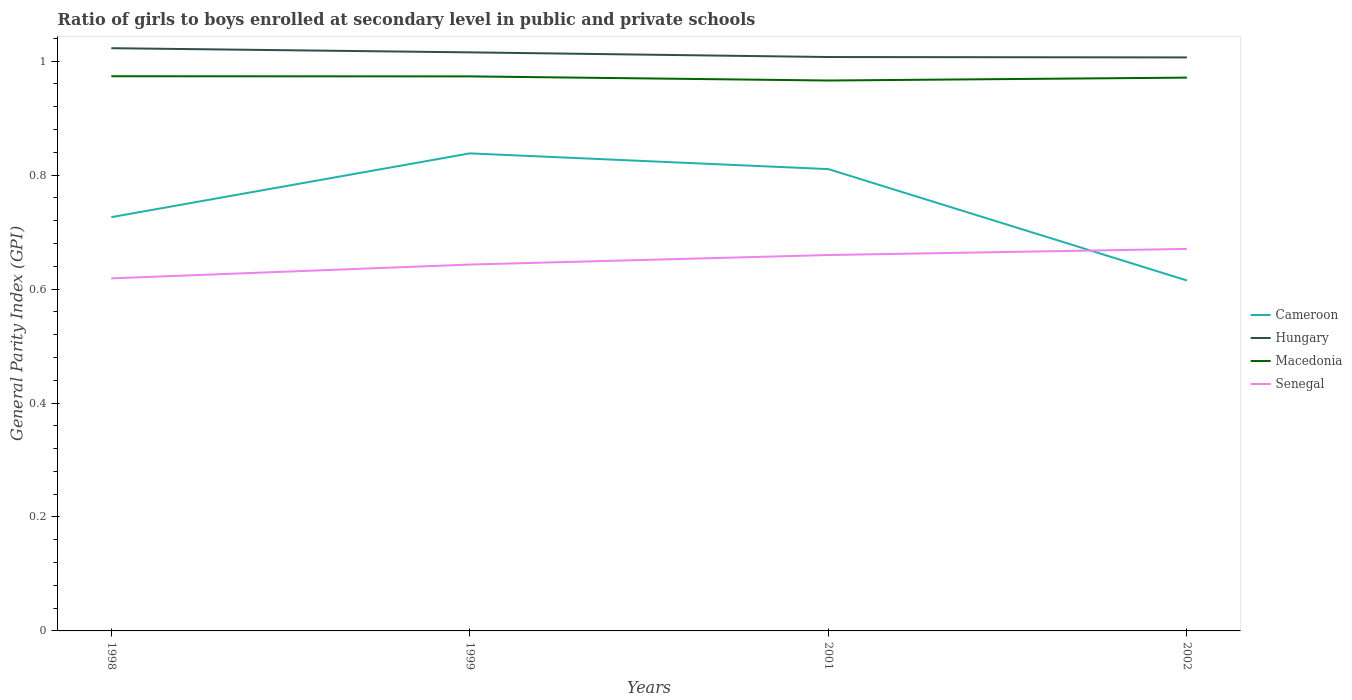Across all years, what is the maximum general parity index in Hungary?
Your answer should be compact. 1.01. What is the total general parity index in Hungary in the graph?
Ensure brevity in your answer.  0.01. What is the difference between the highest and the second highest general parity index in Cameroon?
Offer a terse response. 0.22. What is the difference between the highest and the lowest general parity index in Macedonia?
Keep it short and to the point. 3. Is the general parity index in Senegal strictly greater than the general parity index in Cameroon over the years?
Your response must be concise. No. What is the difference between two consecutive major ticks on the Y-axis?
Provide a succinct answer. 0.2. Does the graph contain any zero values?
Provide a succinct answer. No. What is the title of the graph?
Provide a short and direct response. Ratio of girls to boys enrolled at secondary level in public and private schools. Does "Iceland" appear as one of the legend labels in the graph?
Provide a short and direct response. No. What is the label or title of the Y-axis?
Offer a terse response. General Parity Index (GPI). What is the General Parity Index (GPI) in Cameroon in 1998?
Ensure brevity in your answer.  0.73. What is the General Parity Index (GPI) in Hungary in 1998?
Keep it short and to the point. 1.02. What is the General Parity Index (GPI) in Macedonia in 1998?
Your answer should be compact. 0.97. What is the General Parity Index (GPI) of Senegal in 1998?
Offer a terse response. 0.62. What is the General Parity Index (GPI) of Cameroon in 1999?
Your response must be concise. 0.84. What is the General Parity Index (GPI) in Hungary in 1999?
Your answer should be compact. 1.02. What is the General Parity Index (GPI) in Macedonia in 1999?
Your response must be concise. 0.97. What is the General Parity Index (GPI) in Senegal in 1999?
Offer a terse response. 0.64. What is the General Parity Index (GPI) in Cameroon in 2001?
Give a very brief answer. 0.81. What is the General Parity Index (GPI) in Hungary in 2001?
Provide a short and direct response. 1.01. What is the General Parity Index (GPI) of Macedonia in 2001?
Provide a succinct answer. 0.97. What is the General Parity Index (GPI) of Senegal in 2001?
Your answer should be compact. 0.66. What is the General Parity Index (GPI) in Cameroon in 2002?
Provide a succinct answer. 0.62. What is the General Parity Index (GPI) in Hungary in 2002?
Provide a short and direct response. 1.01. What is the General Parity Index (GPI) of Macedonia in 2002?
Offer a very short reply. 0.97. What is the General Parity Index (GPI) of Senegal in 2002?
Keep it short and to the point. 0.67. Across all years, what is the maximum General Parity Index (GPI) in Cameroon?
Your response must be concise. 0.84. Across all years, what is the maximum General Parity Index (GPI) in Hungary?
Ensure brevity in your answer.  1.02. Across all years, what is the maximum General Parity Index (GPI) in Macedonia?
Ensure brevity in your answer.  0.97. Across all years, what is the maximum General Parity Index (GPI) in Senegal?
Your answer should be very brief. 0.67. Across all years, what is the minimum General Parity Index (GPI) of Cameroon?
Your answer should be very brief. 0.62. Across all years, what is the minimum General Parity Index (GPI) of Hungary?
Your answer should be compact. 1.01. Across all years, what is the minimum General Parity Index (GPI) in Macedonia?
Make the answer very short. 0.97. Across all years, what is the minimum General Parity Index (GPI) of Senegal?
Provide a succinct answer. 0.62. What is the total General Parity Index (GPI) of Cameroon in the graph?
Your response must be concise. 2.99. What is the total General Parity Index (GPI) of Hungary in the graph?
Offer a terse response. 4.05. What is the total General Parity Index (GPI) in Macedonia in the graph?
Offer a terse response. 3.88. What is the total General Parity Index (GPI) in Senegal in the graph?
Offer a terse response. 2.59. What is the difference between the General Parity Index (GPI) of Cameroon in 1998 and that in 1999?
Offer a terse response. -0.11. What is the difference between the General Parity Index (GPI) in Hungary in 1998 and that in 1999?
Provide a short and direct response. 0.01. What is the difference between the General Parity Index (GPI) in Senegal in 1998 and that in 1999?
Your answer should be compact. -0.02. What is the difference between the General Parity Index (GPI) in Cameroon in 1998 and that in 2001?
Offer a very short reply. -0.08. What is the difference between the General Parity Index (GPI) in Hungary in 1998 and that in 2001?
Provide a short and direct response. 0.02. What is the difference between the General Parity Index (GPI) in Macedonia in 1998 and that in 2001?
Make the answer very short. 0.01. What is the difference between the General Parity Index (GPI) in Senegal in 1998 and that in 2001?
Keep it short and to the point. -0.04. What is the difference between the General Parity Index (GPI) of Cameroon in 1998 and that in 2002?
Provide a short and direct response. 0.11. What is the difference between the General Parity Index (GPI) of Hungary in 1998 and that in 2002?
Provide a succinct answer. 0.02. What is the difference between the General Parity Index (GPI) in Macedonia in 1998 and that in 2002?
Offer a very short reply. 0. What is the difference between the General Parity Index (GPI) of Senegal in 1998 and that in 2002?
Offer a terse response. -0.05. What is the difference between the General Parity Index (GPI) of Cameroon in 1999 and that in 2001?
Give a very brief answer. 0.03. What is the difference between the General Parity Index (GPI) of Hungary in 1999 and that in 2001?
Provide a succinct answer. 0.01. What is the difference between the General Parity Index (GPI) in Macedonia in 1999 and that in 2001?
Your answer should be very brief. 0.01. What is the difference between the General Parity Index (GPI) of Senegal in 1999 and that in 2001?
Ensure brevity in your answer.  -0.02. What is the difference between the General Parity Index (GPI) of Cameroon in 1999 and that in 2002?
Your answer should be compact. 0.22. What is the difference between the General Parity Index (GPI) in Hungary in 1999 and that in 2002?
Your answer should be very brief. 0.01. What is the difference between the General Parity Index (GPI) of Macedonia in 1999 and that in 2002?
Give a very brief answer. 0. What is the difference between the General Parity Index (GPI) in Senegal in 1999 and that in 2002?
Ensure brevity in your answer.  -0.03. What is the difference between the General Parity Index (GPI) of Cameroon in 2001 and that in 2002?
Offer a very short reply. 0.2. What is the difference between the General Parity Index (GPI) of Hungary in 2001 and that in 2002?
Your response must be concise. 0. What is the difference between the General Parity Index (GPI) in Macedonia in 2001 and that in 2002?
Offer a very short reply. -0.01. What is the difference between the General Parity Index (GPI) in Senegal in 2001 and that in 2002?
Give a very brief answer. -0.01. What is the difference between the General Parity Index (GPI) of Cameroon in 1998 and the General Parity Index (GPI) of Hungary in 1999?
Ensure brevity in your answer.  -0.29. What is the difference between the General Parity Index (GPI) in Cameroon in 1998 and the General Parity Index (GPI) in Macedonia in 1999?
Provide a short and direct response. -0.25. What is the difference between the General Parity Index (GPI) of Cameroon in 1998 and the General Parity Index (GPI) of Senegal in 1999?
Keep it short and to the point. 0.08. What is the difference between the General Parity Index (GPI) of Hungary in 1998 and the General Parity Index (GPI) of Macedonia in 1999?
Make the answer very short. 0.05. What is the difference between the General Parity Index (GPI) in Hungary in 1998 and the General Parity Index (GPI) in Senegal in 1999?
Provide a succinct answer. 0.38. What is the difference between the General Parity Index (GPI) in Macedonia in 1998 and the General Parity Index (GPI) in Senegal in 1999?
Make the answer very short. 0.33. What is the difference between the General Parity Index (GPI) in Cameroon in 1998 and the General Parity Index (GPI) in Hungary in 2001?
Your answer should be very brief. -0.28. What is the difference between the General Parity Index (GPI) of Cameroon in 1998 and the General Parity Index (GPI) of Macedonia in 2001?
Provide a succinct answer. -0.24. What is the difference between the General Parity Index (GPI) of Cameroon in 1998 and the General Parity Index (GPI) of Senegal in 2001?
Give a very brief answer. 0.07. What is the difference between the General Parity Index (GPI) in Hungary in 1998 and the General Parity Index (GPI) in Macedonia in 2001?
Provide a short and direct response. 0.06. What is the difference between the General Parity Index (GPI) of Hungary in 1998 and the General Parity Index (GPI) of Senegal in 2001?
Your response must be concise. 0.36. What is the difference between the General Parity Index (GPI) in Macedonia in 1998 and the General Parity Index (GPI) in Senegal in 2001?
Offer a very short reply. 0.31. What is the difference between the General Parity Index (GPI) in Cameroon in 1998 and the General Parity Index (GPI) in Hungary in 2002?
Provide a short and direct response. -0.28. What is the difference between the General Parity Index (GPI) in Cameroon in 1998 and the General Parity Index (GPI) in Macedonia in 2002?
Offer a very short reply. -0.24. What is the difference between the General Parity Index (GPI) in Cameroon in 1998 and the General Parity Index (GPI) in Senegal in 2002?
Offer a very short reply. 0.06. What is the difference between the General Parity Index (GPI) in Hungary in 1998 and the General Parity Index (GPI) in Macedonia in 2002?
Give a very brief answer. 0.05. What is the difference between the General Parity Index (GPI) of Hungary in 1998 and the General Parity Index (GPI) of Senegal in 2002?
Provide a succinct answer. 0.35. What is the difference between the General Parity Index (GPI) in Macedonia in 1998 and the General Parity Index (GPI) in Senegal in 2002?
Your answer should be compact. 0.3. What is the difference between the General Parity Index (GPI) in Cameroon in 1999 and the General Parity Index (GPI) in Hungary in 2001?
Your response must be concise. -0.17. What is the difference between the General Parity Index (GPI) in Cameroon in 1999 and the General Parity Index (GPI) in Macedonia in 2001?
Your answer should be very brief. -0.13. What is the difference between the General Parity Index (GPI) of Cameroon in 1999 and the General Parity Index (GPI) of Senegal in 2001?
Give a very brief answer. 0.18. What is the difference between the General Parity Index (GPI) of Hungary in 1999 and the General Parity Index (GPI) of Macedonia in 2001?
Give a very brief answer. 0.05. What is the difference between the General Parity Index (GPI) of Hungary in 1999 and the General Parity Index (GPI) of Senegal in 2001?
Your response must be concise. 0.36. What is the difference between the General Parity Index (GPI) in Macedonia in 1999 and the General Parity Index (GPI) in Senegal in 2001?
Offer a very short reply. 0.31. What is the difference between the General Parity Index (GPI) of Cameroon in 1999 and the General Parity Index (GPI) of Hungary in 2002?
Your response must be concise. -0.17. What is the difference between the General Parity Index (GPI) in Cameroon in 1999 and the General Parity Index (GPI) in Macedonia in 2002?
Give a very brief answer. -0.13. What is the difference between the General Parity Index (GPI) in Cameroon in 1999 and the General Parity Index (GPI) in Senegal in 2002?
Offer a terse response. 0.17. What is the difference between the General Parity Index (GPI) in Hungary in 1999 and the General Parity Index (GPI) in Macedonia in 2002?
Your answer should be very brief. 0.04. What is the difference between the General Parity Index (GPI) in Hungary in 1999 and the General Parity Index (GPI) in Senegal in 2002?
Offer a terse response. 0.34. What is the difference between the General Parity Index (GPI) of Macedonia in 1999 and the General Parity Index (GPI) of Senegal in 2002?
Keep it short and to the point. 0.3. What is the difference between the General Parity Index (GPI) of Cameroon in 2001 and the General Parity Index (GPI) of Hungary in 2002?
Offer a very short reply. -0.2. What is the difference between the General Parity Index (GPI) of Cameroon in 2001 and the General Parity Index (GPI) of Macedonia in 2002?
Give a very brief answer. -0.16. What is the difference between the General Parity Index (GPI) of Cameroon in 2001 and the General Parity Index (GPI) of Senegal in 2002?
Offer a terse response. 0.14. What is the difference between the General Parity Index (GPI) in Hungary in 2001 and the General Parity Index (GPI) in Macedonia in 2002?
Provide a succinct answer. 0.04. What is the difference between the General Parity Index (GPI) of Hungary in 2001 and the General Parity Index (GPI) of Senegal in 2002?
Offer a terse response. 0.34. What is the difference between the General Parity Index (GPI) of Macedonia in 2001 and the General Parity Index (GPI) of Senegal in 2002?
Provide a succinct answer. 0.3. What is the average General Parity Index (GPI) of Cameroon per year?
Make the answer very short. 0.75. What is the average General Parity Index (GPI) of Hungary per year?
Ensure brevity in your answer.  1.01. What is the average General Parity Index (GPI) of Macedonia per year?
Your answer should be compact. 0.97. What is the average General Parity Index (GPI) of Senegal per year?
Keep it short and to the point. 0.65. In the year 1998, what is the difference between the General Parity Index (GPI) of Cameroon and General Parity Index (GPI) of Hungary?
Make the answer very short. -0.3. In the year 1998, what is the difference between the General Parity Index (GPI) in Cameroon and General Parity Index (GPI) in Macedonia?
Your answer should be compact. -0.25. In the year 1998, what is the difference between the General Parity Index (GPI) of Cameroon and General Parity Index (GPI) of Senegal?
Give a very brief answer. 0.11. In the year 1998, what is the difference between the General Parity Index (GPI) in Hungary and General Parity Index (GPI) in Macedonia?
Offer a very short reply. 0.05. In the year 1998, what is the difference between the General Parity Index (GPI) of Hungary and General Parity Index (GPI) of Senegal?
Offer a terse response. 0.4. In the year 1998, what is the difference between the General Parity Index (GPI) of Macedonia and General Parity Index (GPI) of Senegal?
Your response must be concise. 0.35. In the year 1999, what is the difference between the General Parity Index (GPI) in Cameroon and General Parity Index (GPI) in Hungary?
Give a very brief answer. -0.18. In the year 1999, what is the difference between the General Parity Index (GPI) of Cameroon and General Parity Index (GPI) of Macedonia?
Your response must be concise. -0.14. In the year 1999, what is the difference between the General Parity Index (GPI) in Cameroon and General Parity Index (GPI) in Senegal?
Your response must be concise. 0.2. In the year 1999, what is the difference between the General Parity Index (GPI) of Hungary and General Parity Index (GPI) of Macedonia?
Make the answer very short. 0.04. In the year 1999, what is the difference between the General Parity Index (GPI) of Hungary and General Parity Index (GPI) of Senegal?
Your answer should be compact. 0.37. In the year 1999, what is the difference between the General Parity Index (GPI) in Macedonia and General Parity Index (GPI) in Senegal?
Ensure brevity in your answer.  0.33. In the year 2001, what is the difference between the General Parity Index (GPI) in Cameroon and General Parity Index (GPI) in Hungary?
Make the answer very short. -0.2. In the year 2001, what is the difference between the General Parity Index (GPI) of Cameroon and General Parity Index (GPI) of Macedonia?
Your answer should be compact. -0.16. In the year 2001, what is the difference between the General Parity Index (GPI) of Cameroon and General Parity Index (GPI) of Senegal?
Your answer should be compact. 0.15. In the year 2001, what is the difference between the General Parity Index (GPI) in Hungary and General Parity Index (GPI) in Macedonia?
Provide a short and direct response. 0.04. In the year 2001, what is the difference between the General Parity Index (GPI) of Hungary and General Parity Index (GPI) of Senegal?
Provide a short and direct response. 0.35. In the year 2001, what is the difference between the General Parity Index (GPI) in Macedonia and General Parity Index (GPI) in Senegal?
Make the answer very short. 0.31. In the year 2002, what is the difference between the General Parity Index (GPI) of Cameroon and General Parity Index (GPI) of Hungary?
Make the answer very short. -0.39. In the year 2002, what is the difference between the General Parity Index (GPI) in Cameroon and General Parity Index (GPI) in Macedonia?
Make the answer very short. -0.36. In the year 2002, what is the difference between the General Parity Index (GPI) in Cameroon and General Parity Index (GPI) in Senegal?
Ensure brevity in your answer.  -0.06. In the year 2002, what is the difference between the General Parity Index (GPI) of Hungary and General Parity Index (GPI) of Macedonia?
Make the answer very short. 0.04. In the year 2002, what is the difference between the General Parity Index (GPI) in Hungary and General Parity Index (GPI) in Senegal?
Give a very brief answer. 0.34. In the year 2002, what is the difference between the General Parity Index (GPI) of Macedonia and General Parity Index (GPI) of Senegal?
Your response must be concise. 0.3. What is the ratio of the General Parity Index (GPI) of Cameroon in 1998 to that in 1999?
Provide a succinct answer. 0.87. What is the ratio of the General Parity Index (GPI) in Hungary in 1998 to that in 1999?
Make the answer very short. 1.01. What is the ratio of the General Parity Index (GPI) of Senegal in 1998 to that in 1999?
Your response must be concise. 0.96. What is the ratio of the General Parity Index (GPI) in Cameroon in 1998 to that in 2001?
Provide a succinct answer. 0.9. What is the ratio of the General Parity Index (GPI) of Hungary in 1998 to that in 2001?
Make the answer very short. 1.02. What is the ratio of the General Parity Index (GPI) of Macedonia in 1998 to that in 2001?
Offer a very short reply. 1.01. What is the ratio of the General Parity Index (GPI) of Senegal in 1998 to that in 2001?
Your answer should be compact. 0.94. What is the ratio of the General Parity Index (GPI) of Cameroon in 1998 to that in 2002?
Your response must be concise. 1.18. What is the ratio of the General Parity Index (GPI) of Hungary in 1998 to that in 2002?
Keep it short and to the point. 1.02. What is the ratio of the General Parity Index (GPI) of Macedonia in 1998 to that in 2002?
Provide a succinct answer. 1. What is the ratio of the General Parity Index (GPI) in Senegal in 1998 to that in 2002?
Keep it short and to the point. 0.92. What is the ratio of the General Parity Index (GPI) of Cameroon in 1999 to that in 2001?
Provide a short and direct response. 1.03. What is the ratio of the General Parity Index (GPI) in Hungary in 1999 to that in 2001?
Offer a very short reply. 1.01. What is the ratio of the General Parity Index (GPI) in Macedonia in 1999 to that in 2001?
Offer a terse response. 1.01. What is the ratio of the General Parity Index (GPI) in Senegal in 1999 to that in 2001?
Offer a terse response. 0.97. What is the ratio of the General Parity Index (GPI) in Cameroon in 1999 to that in 2002?
Keep it short and to the point. 1.36. What is the ratio of the General Parity Index (GPI) of Hungary in 1999 to that in 2002?
Make the answer very short. 1.01. What is the ratio of the General Parity Index (GPI) of Senegal in 1999 to that in 2002?
Provide a succinct answer. 0.96. What is the ratio of the General Parity Index (GPI) of Cameroon in 2001 to that in 2002?
Offer a terse response. 1.32. What is the ratio of the General Parity Index (GPI) of Hungary in 2001 to that in 2002?
Your response must be concise. 1. What is the ratio of the General Parity Index (GPI) of Macedonia in 2001 to that in 2002?
Your answer should be very brief. 0.99. What is the ratio of the General Parity Index (GPI) in Senegal in 2001 to that in 2002?
Offer a terse response. 0.98. What is the difference between the highest and the second highest General Parity Index (GPI) in Cameroon?
Your response must be concise. 0.03. What is the difference between the highest and the second highest General Parity Index (GPI) in Hungary?
Your response must be concise. 0.01. What is the difference between the highest and the second highest General Parity Index (GPI) of Senegal?
Give a very brief answer. 0.01. What is the difference between the highest and the lowest General Parity Index (GPI) in Cameroon?
Your answer should be compact. 0.22. What is the difference between the highest and the lowest General Parity Index (GPI) in Hungary?
Give a very brief answer. 0.02. What is the difference between the highest and the lowest General Parity Index (GPI) in Macedonia?
Your answer should be compact. 0.01. What is the difference between the highest and the lowest General Parity Index (GPI) of Senegal?
Keep it short and to the point. 0.05. 